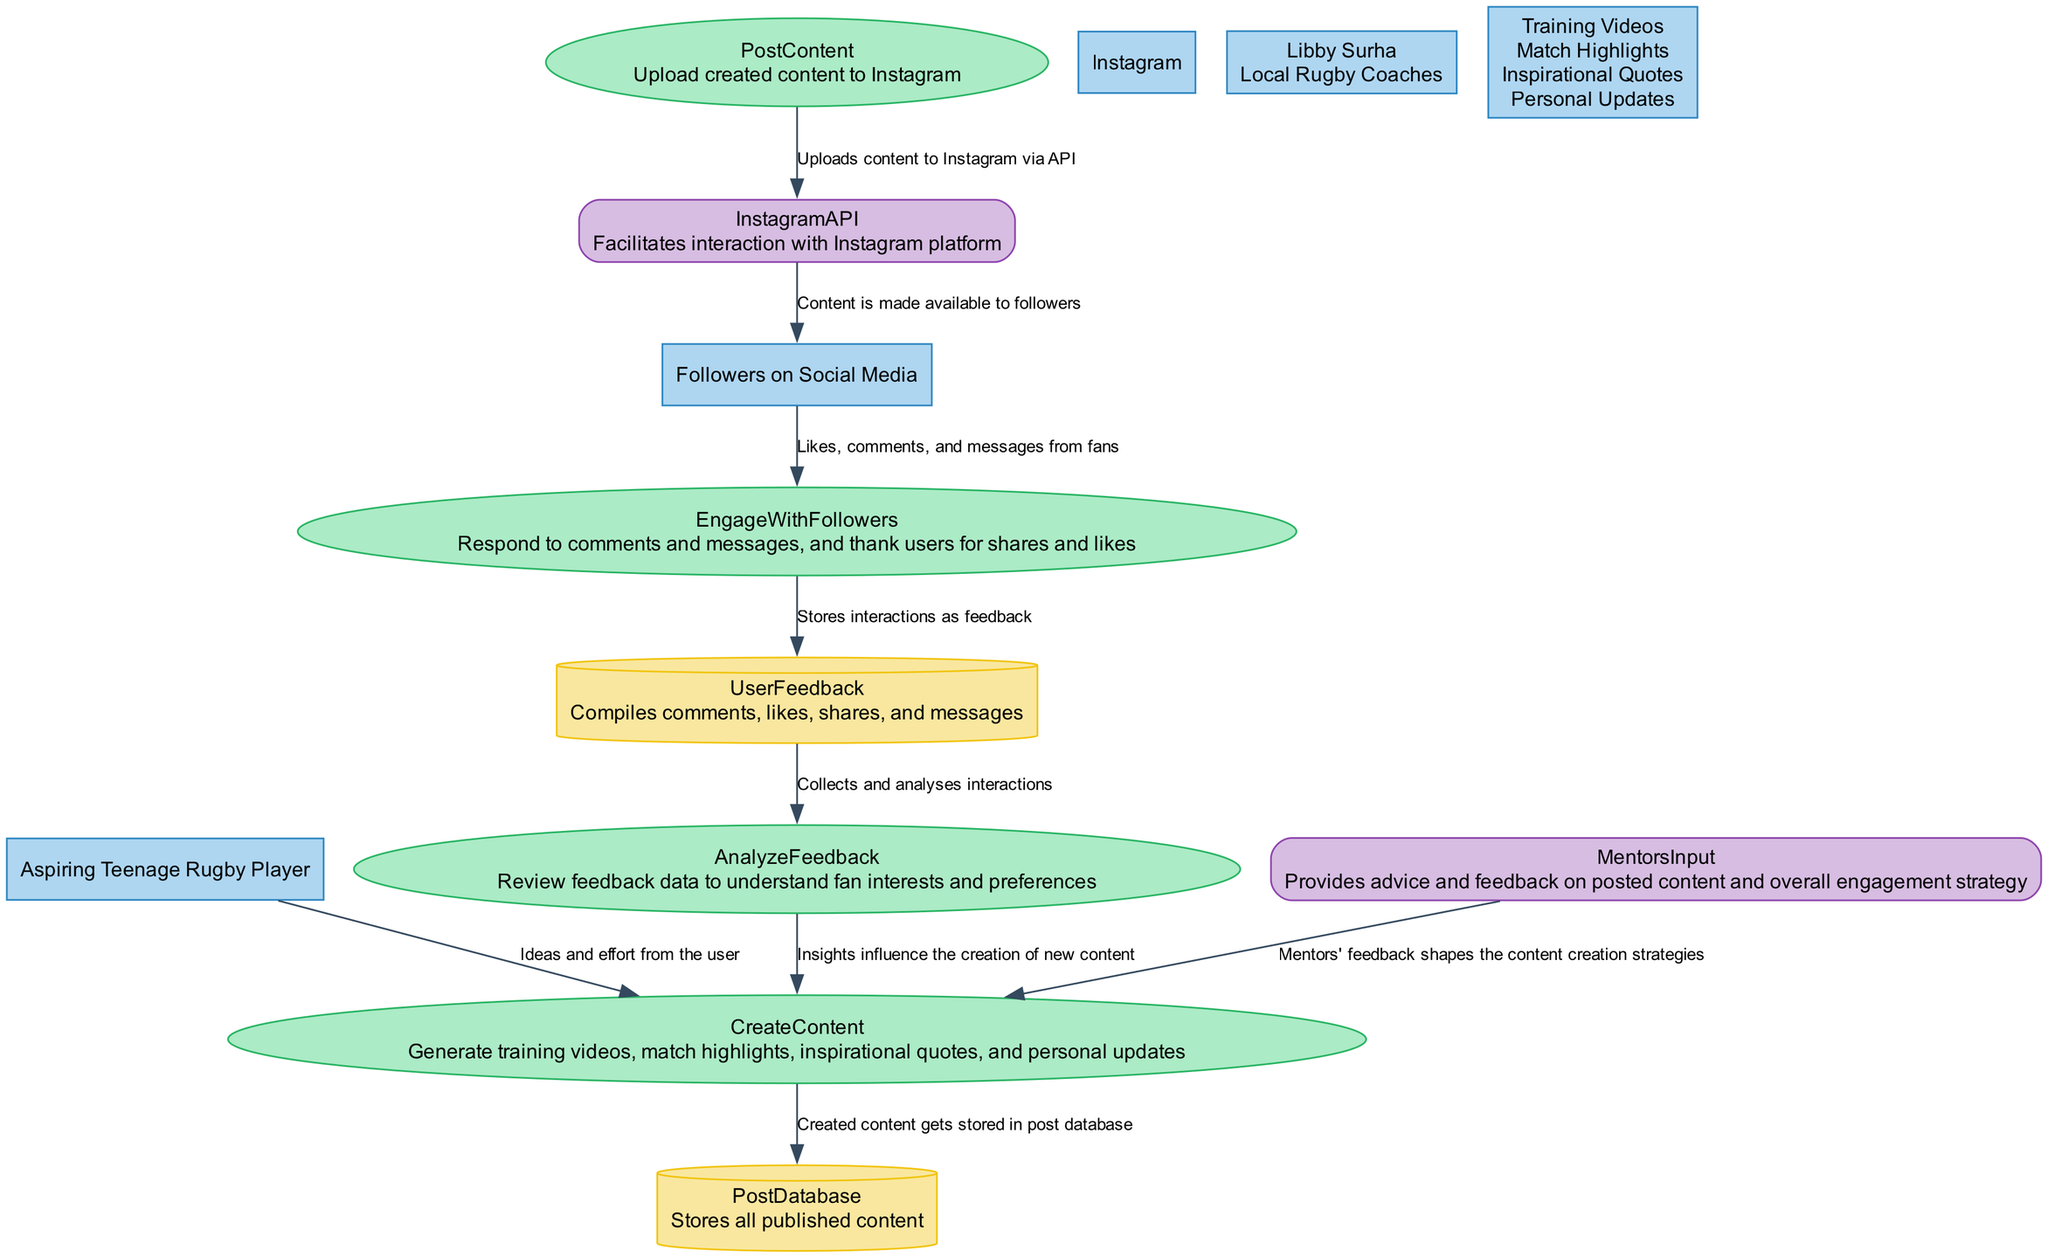What is the main social media platform used in this engagement strategy? The diagram clearly identifies Instagram as the primary social media platform involved in the engagement strategy.
Answer: Instagram How many types of content are created according to the diagram? The diagram lists four types of content: training videos, match highlights, inspirational quotes, and personal updates. By counting these, we confirm that there are four types.
Answer: Four What process is responsible for storing interactions as feedback? The diagram indicates that "EngageWithFollowers" process stores interactions as feedback to the "UserFeedback" data store.
Answer: EngageWithFollowers Which external entity provides feedback on the content creation strategies? According to the diagram, "MentorsInput" supplies advice and feedback to shape the content creation strategies, making it the external entity in question.
Answer: MentorsInput How does created content reach the fans? The diagram shows that the content flows from "PostContent" to "InstagramAPI," which then distributes the content to the fans. This series of actions indicates the process by which fans access the content.
Answer: InstagramAPI What influences the creation of new content based on user interactions? The diagram specifies that the "AnalyzeFeedback" process collects and analyzes interactions from the "UserFeedback" data store, which then influences the new content creation, showing the relationship between feedback and content generation.
Answer: AnalyzeFeedback What type of node is "PostDatabase"? In the diagram, "PostDatabase" is represented as a cylinder, which typically denotes a data store in a Data Flow Diagram.
Answer: Cylinder How does a user initially contribute to the content creation process? The flow diagram illustrates that "UserToCreateContent" reflects that the user contributes ideas and effort towards creating content, highlighting the user's role in the initial stage.
Answer: Ideas and effort What role does the InstagramAPI play in the diagram? The InstagramAPI functions as an external entity that facilitates interaction with the Instagram platform, allowing posted content to reach fans. This role is established within the flow of content from the user to the fans.
Answer: Facilitates interaction 